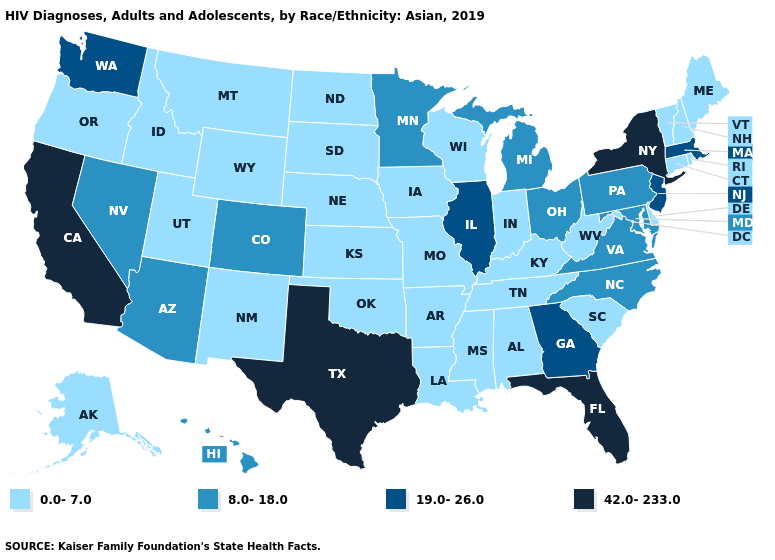What is the value of Alabama?
Keep it brief. 0.0-7.0. What is the value of Missouri?
Write a very short answer. 0.0-7.0. Does the map have missing data?
Concise answer only. No. Does Indiana have the highest value in the USA?
Keep it brief. No. Among the states that border North Carolina , does Tennessee have the lowest value?
Short answer required. Yes. Is the legend a continuous bar?
Concise answer only. No. What is the highest value in states that border New Mexico?
Quick response, please. 42.0-233.0. What is the value of Delaware?
Keep it brief. 0.0-7.0. Is the legend a continuous bar?
Write a very short answer. No. Does Mississippi have the same value as Alabama?
Quick response, please. Yes. What is the lowest value in the USA?
Concise answer only. 0.0-7.0. Does the first symbol in the legend represent the smallest category?
Keep it brief. Yes. What is the highest value in the West ?
Give a very brief answer. 42.0-233.0. Among the states that border Louisiana , which have the lowest value?
Short answer required. Arkansas, Mississippi. 